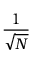Convert formula to latex. <formula><loc_0><loc_0><loc_500><loc_500>\frac { 1 } { \sqrt { N } }</formula> 